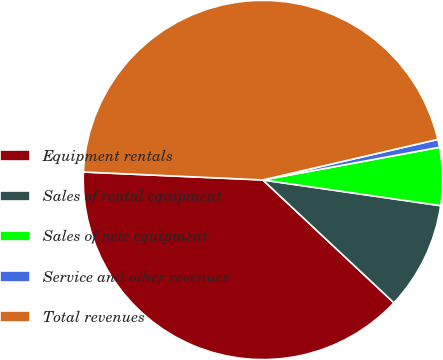Convert chart. <chart><loc_0><loc_0><loc_500><loc_500><pie_chart><fcel>Equipment rentals<fcel>Sales of rental equipment<fcel>Sales of new equipment<fcel>Service and other revenues<fcel>Total revenues<nl><fcel>38.72%<fcel>9.7%<fcel>5.2%<fcel>0.71%<fcel>45.67%<nl></chart> 